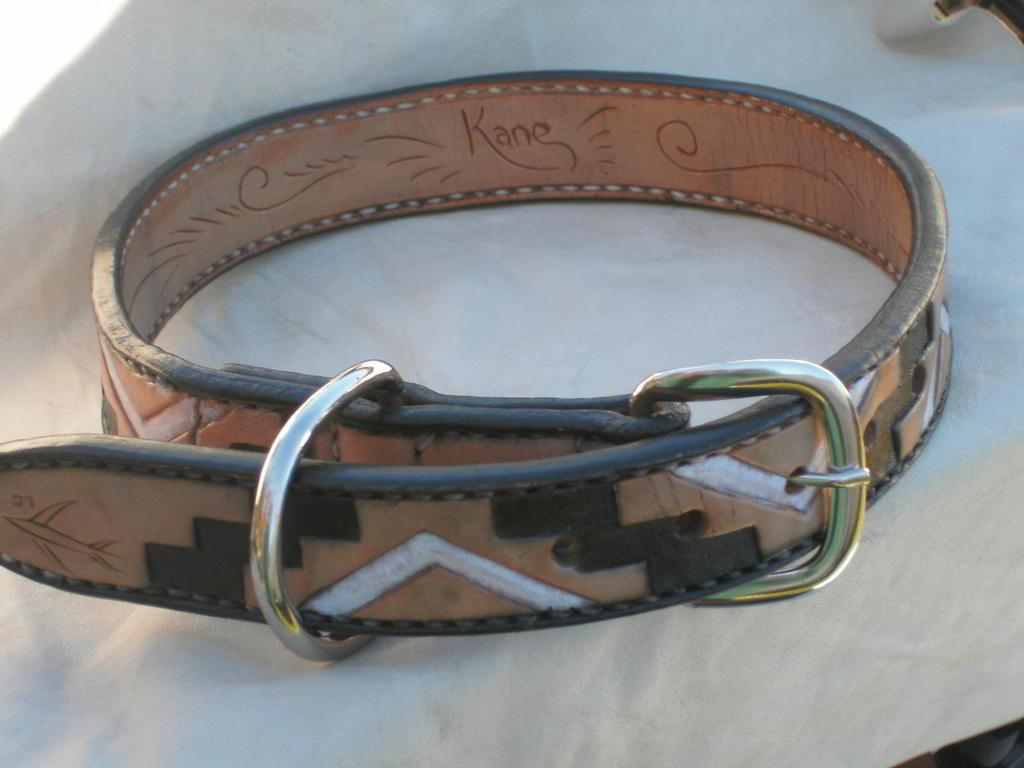Provide a one-sentence caption for the provided image. A leather wrist band with gold buckle and an engraving that says Kane. 